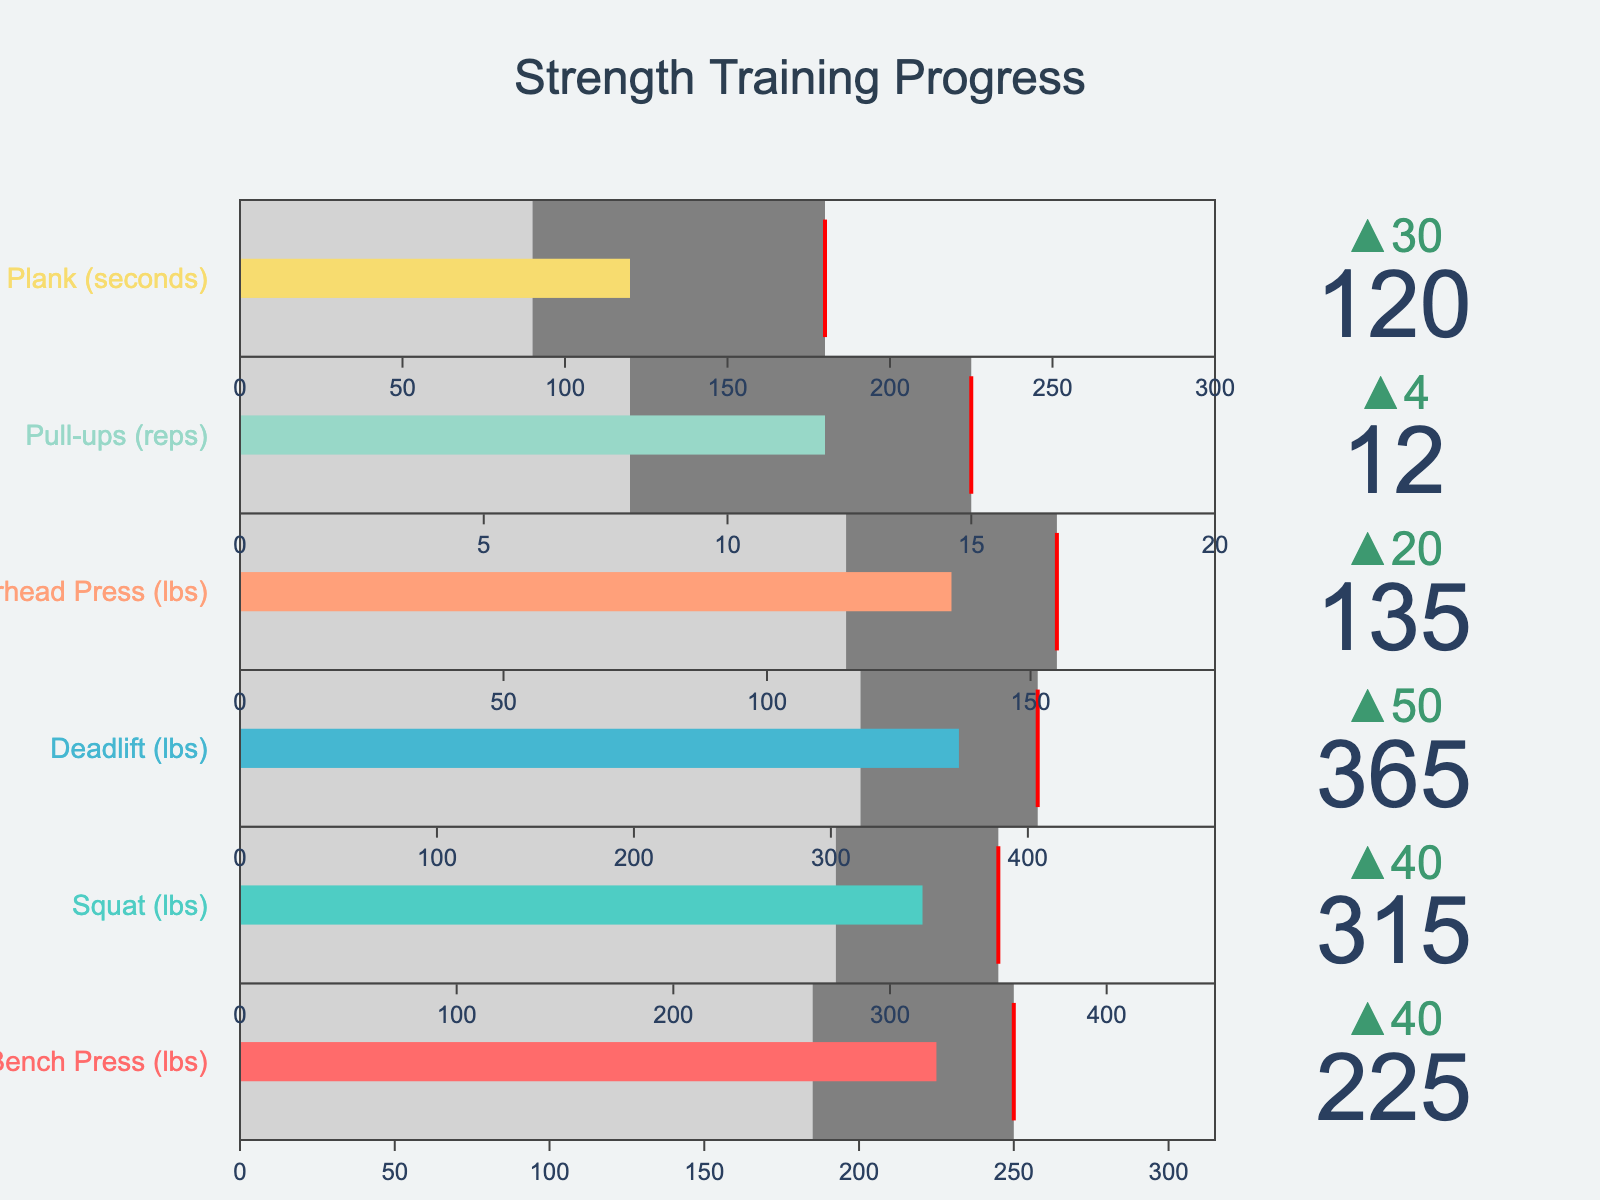What is the title of the figure? The title is usually prominently displayed at the top of the figure. In this case, we can look at the large text at the top center of the figure to find the title.
Answer: "Strength Training Progress" Which exercise has the highest personal record? By comparing all the personal record values mentioned for each exercise listed in the figure, we see that the Deadlift has the highest value.
Answer: Deadlift What is your goal for the Bench Press, and how close are you to achieving it? The goal value for the Bench Press can be read directly from the relevant bullet chart. Subtract the personal record from this goal to gauge how close you are. The goal is 250 lbs, and the personal record is 225 lbs, hence the difference is 250 - 225 = 25 lbs.
Answer: 250 lbs, 25 lbs away Are your personal records for Squat and Deadlift above the average? To find this, we compare the personal records for Squat (315 lbs) and Deadlift (365 lbs) against their respective averages (275 lbs for Squat, 315 lbs for Deadlift). Both personal records are greater than the averages.
Answer: Yes Which exercise is the closest to its elite benchmark, relative to the difference between personal record and elite benchmark? Compute the difference between the personal records and their elite levels for each exercise. The smallest difference will indicate the closest exercise.
Answer: Bench Press How many exercises have personal records below their goals? Compare each exercise's personal record with its goal to count how many are below. Personal record for Bench Press (225 lbs) is below its goal (250 lbs), for Squat (315 lbs) is below its goal (350 lbs), for Deadlift (365 lbs) is below its goal (405 lbs), for Overhead Press (135 lbs) is below its goal (155 lbs), and for Plank (120 seconds) is below its goal (180 seconds).
Answer: 5 exercises What is the average value of the fitness industry benchmarks for the listed exercises? First, sum the elite values of all exercises and then divide by the number of exercises. (315 + 450 + 495 + 185 + 20 + 300) / 6 = 1765 / 6 ≈ 294.17
Answer: 294.17 Which exercise shows the greatest improvement over the industry average and by how much? Subtract the industry average for each exercise from its personal record and find the maximum difference. Bench Press improvement is 225 - 185 = 40 lbs, Squat improvement is 315 - 275 = 40 lbs, Deadlift improvement is 365 - 315 = 50 lbs, Overhead Press improvement is 135 - 115 = 20 lbs, Pull-ups improvement is 12 - 8 = 4 reps, Plank improvement is 120 - 90 = 30 seconds. Deadlift has the greatest improvement, which is 365 - 315 = 50 lbs.
Answer: Deadlift, 50 lbs Which exercise has the smallest delta change from the average value? Delta change can be identified as the smallest difference between the personal record and average. By comparing, Overhead Press (difference of 135 - 115 = 20 lbs) has the smallest delta change.
Answer: Overhead Press 